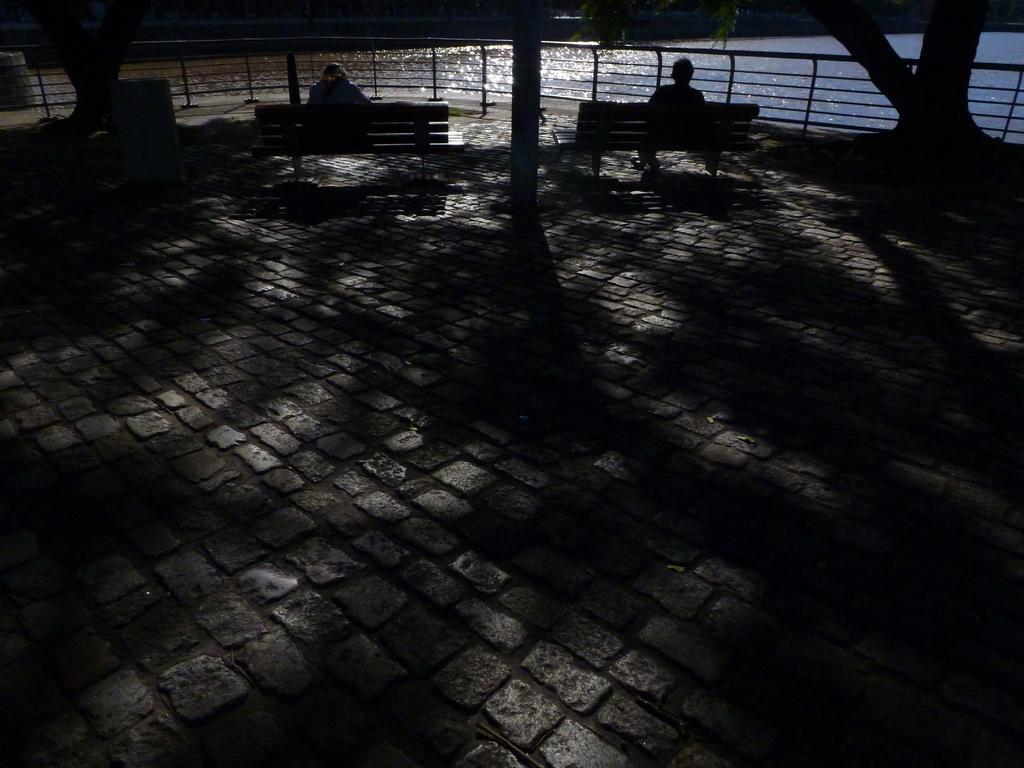In one or two sentences, can you explain what this image depicts? This image is taken during the night time. In this image we can see two persons sitting on two different branches which are on the brick surface. We can also see the trees, fence and also the water in the background. 